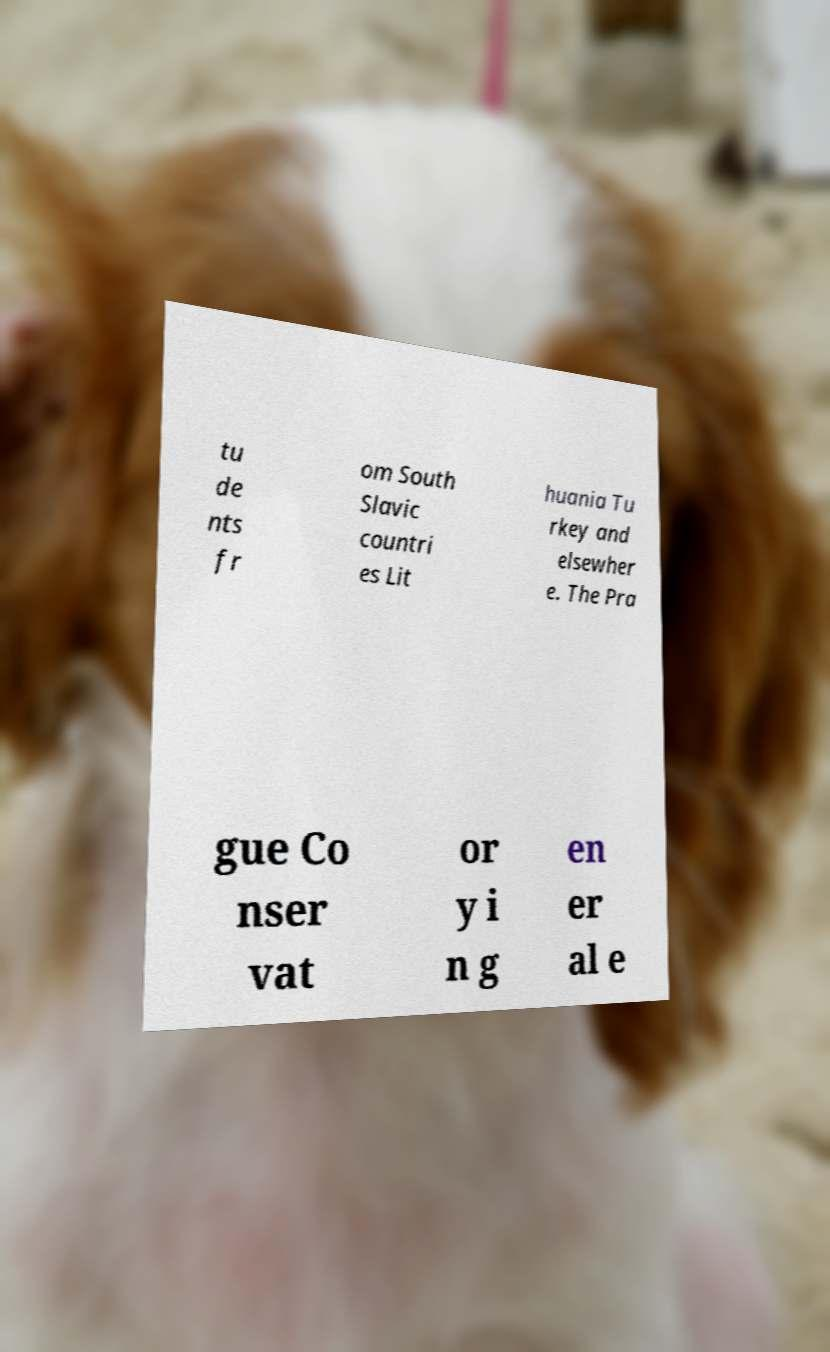What messages or text are displayed in this image? I need them in a readable, typed format. tu de nts fr om South Slavic countri es Lit huania Tu rkey and elsewher e. The Pra gue Co nser vat or y i n g en er al e 